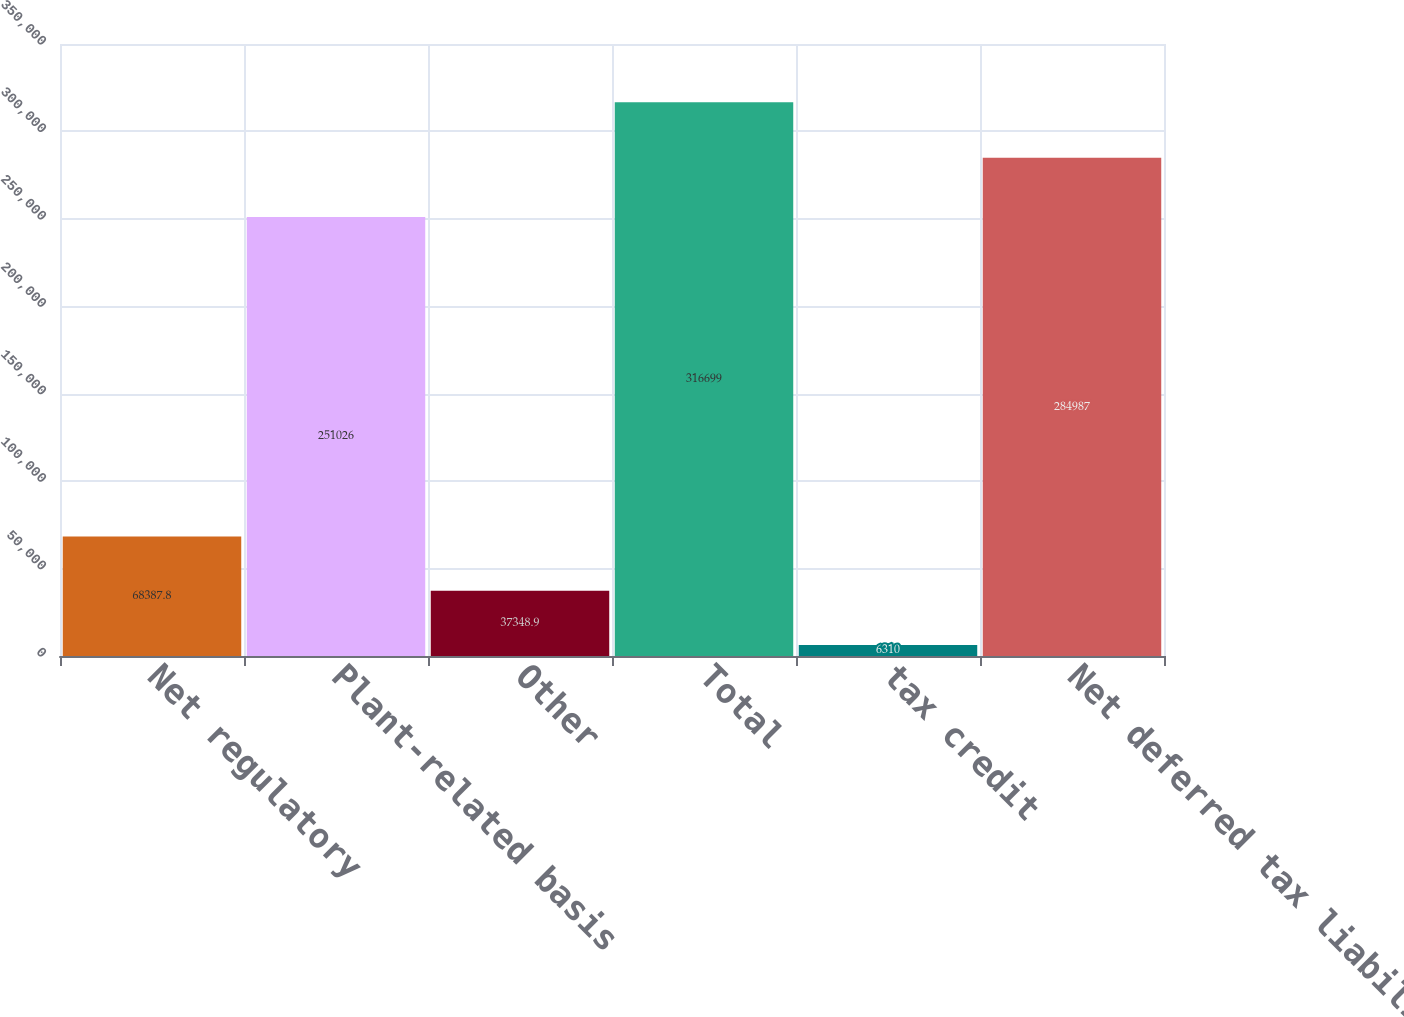<chart> <loc_0><loc_0><loc_500><loc_500><bar_chart><fcel>Net regulatory<fcel>Plant-related basis<fcel>Other<fcel>Total<fcel>tax credit<fcel>Net deferred tax liability<nl><fcel>68387.8<fcel>251026<fcel>37348.9<fcel>316699<fcel>6310<fcel>284987<nl></chart> 